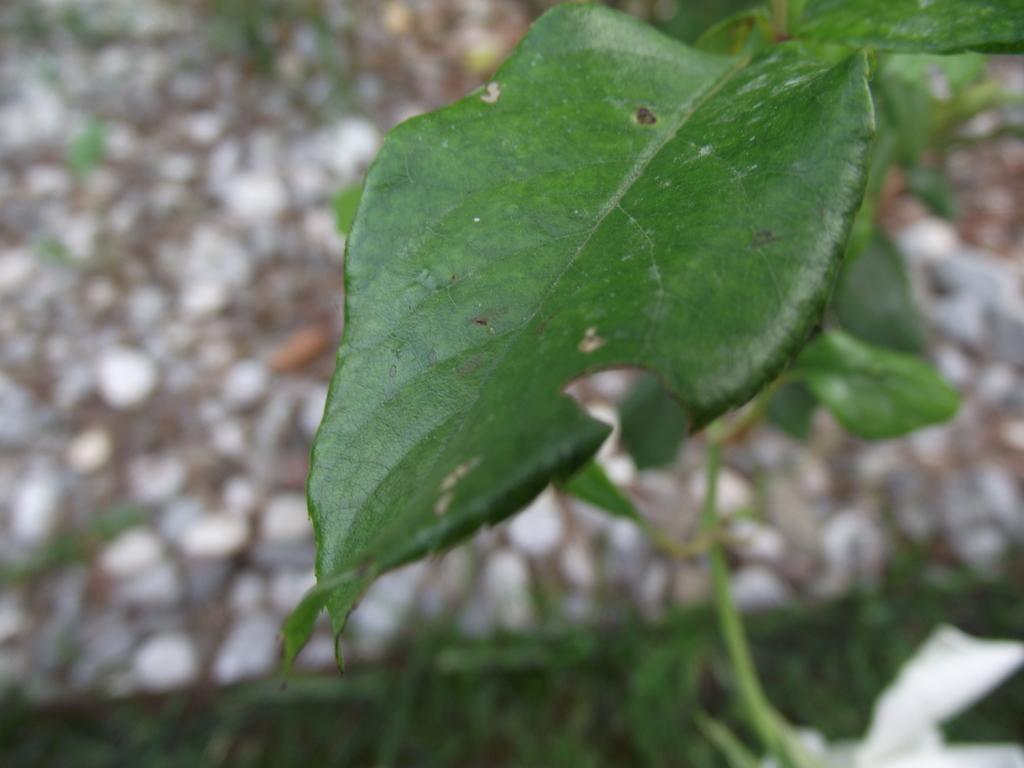Can you describe this image briefly? In this image I can see a green colour leave in the front. In the background I can see few more leaves and I can see this image is little bit blurry in the background. 